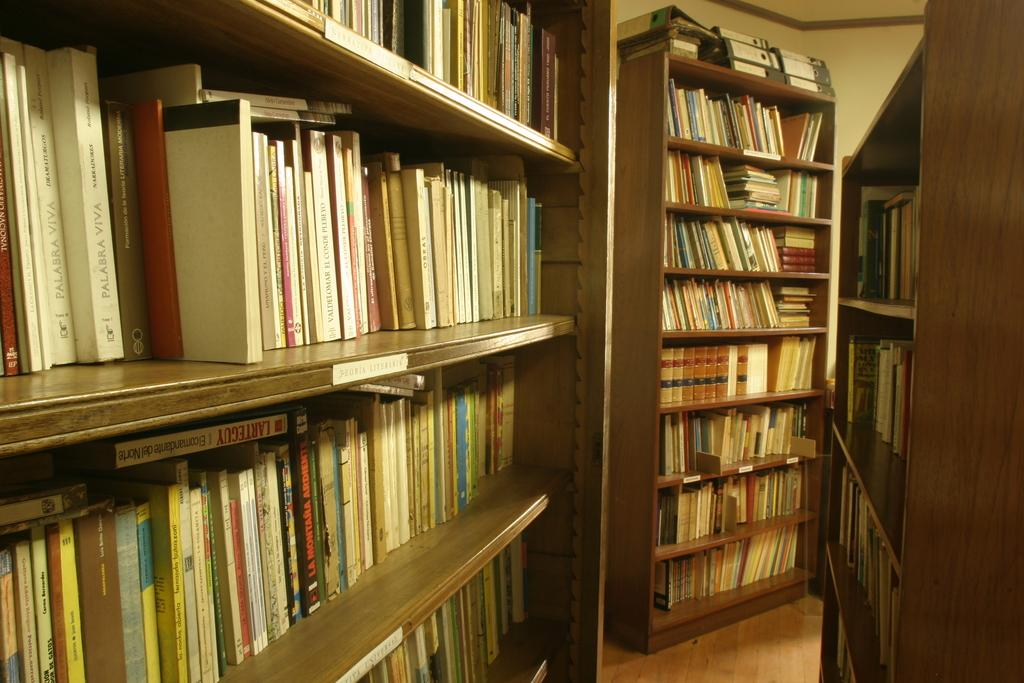What objects are present in the image? There are books in the image. How are the books organized in the image? The books are arranged in cupboards. What level of the building is the bath located in the image? There is no bath present in the image, as it only features books arranged in cupboards. 